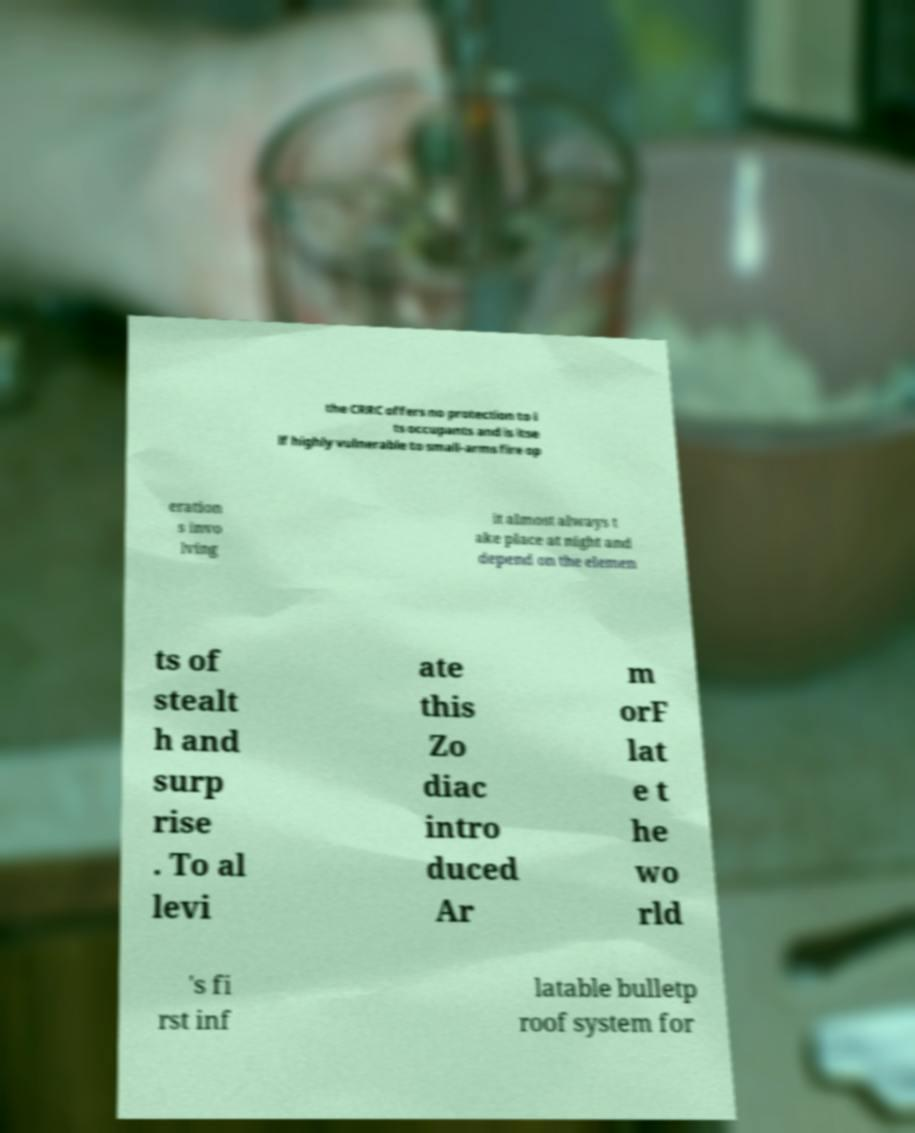I need the written content from this picture converted into text. Can you do that? the CRRC offers no protection to i ts occupants and is itse lf highly vulnerable to small-arms fire op eration s invo lving it almost always t ake place at night and depend on the elemen ts of stealt h and surp rise . To al levi ate this Zo diac intro duced Ar m orF lat e t he wo rld 's fi rst inf latable bulletp roof system for 